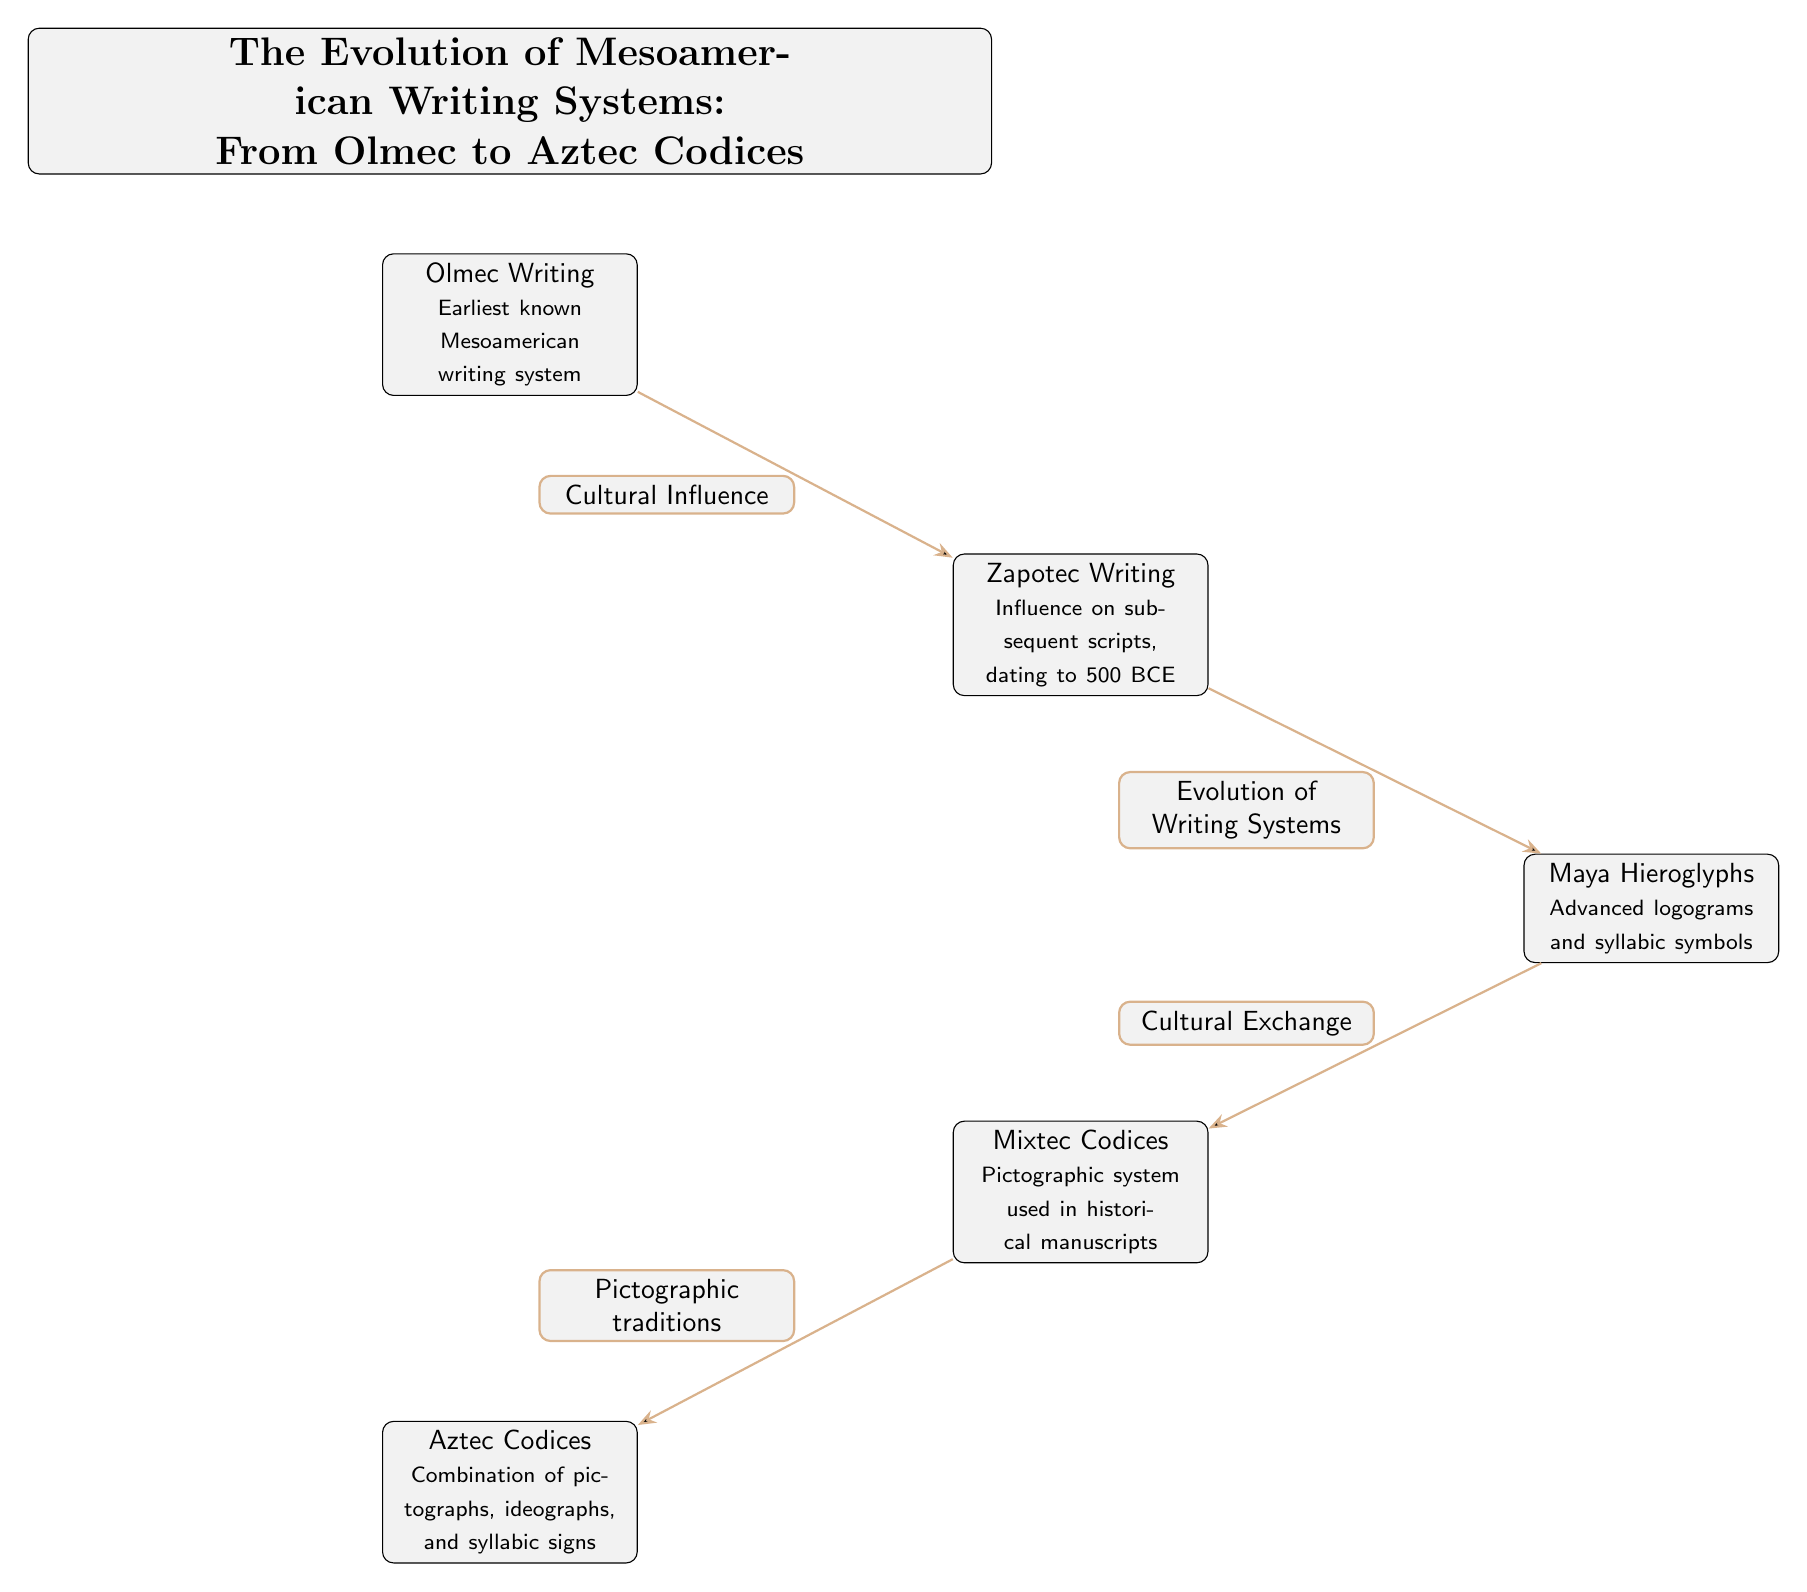What is the earliest known Mesoamerican writing system? The diagram indicates that the "Olmec Writing" is the earliest known Mesoamerican writing system, as it is the first node in the sequence.
Answer: Olmec Writing What type of symbols do Maya hieroglyphs use? The diagram states that "Maya Hieroglyphs" incorporate "Advanced logograms and syllabic symbols," detailing the types of symbols utilized in this writing system.
Answer: Advanced logograms and syllabic symbols How many writing systems are depicted in the diagram? By counting the nodes presented in the diagram, there are a total of five writing systems displayed, each representing a unique historical approach to writing in Mesoamerica.
Answer: 5 What relationship is indicated between Zapotec Writing and Olmec Writing? The diagram shows a directed edge that labels the relationship between "Olmec Writing" and "Zapotec Writing" as "Cultural Influence," indicating how one influenced the other.
Answer: Cultural Influence What do Mixtec Codices primarily represent? According to the diagram, "Mixtec Codices" are described as a "Pictographic system used in historical manuscripts," which explains their primary representational method.
Answer: Pictographic system What type of traditions did Aztec Codices continue from Mixtec? The edge between "Mixtec Codices" and "Aztec Codices" in the diagram is labeled "Pictographic traditions," suggesting that Aztec Codices continued or were influenced by these traditions.
Answer: Pictographic traditions What is the connecting theme between all writing systems depicted? The flow of the diagram suggests a chronological evolution and cultural exchange, linking each writing system, with the first being Olmec writing and the last being Aztec Codices, summarizing the overarching theme of development over time.
Answer: Evolution of Writing Systems Which writing system follows Zapotec Writing in the diagram? The diagram organizes the writing systems sequentially; directly below "Zapotec Writing," the next system is "Maya Hieroglyphs." This structure indicates the progression of writing systems from one to another.
Answer: Maya Hieroglyphs 